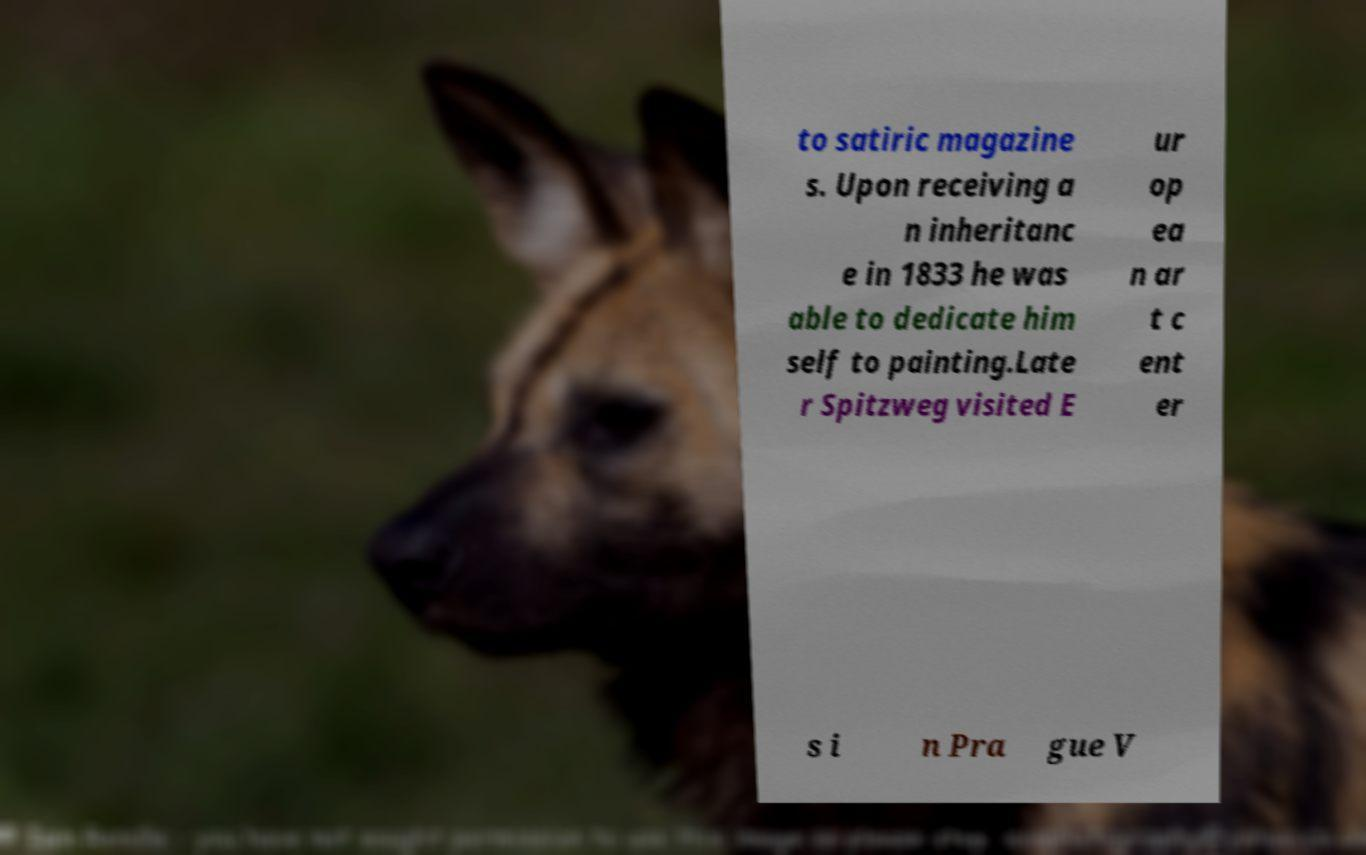Please identify and transcribe the text found in this image. to satiric magazine s. Upon receiving a n inheritanc e in 1833 he was able to dedicate him self to painting.Late r Spitzweg visited E ur op ea n ar t c ent er s i n Pra gue V 